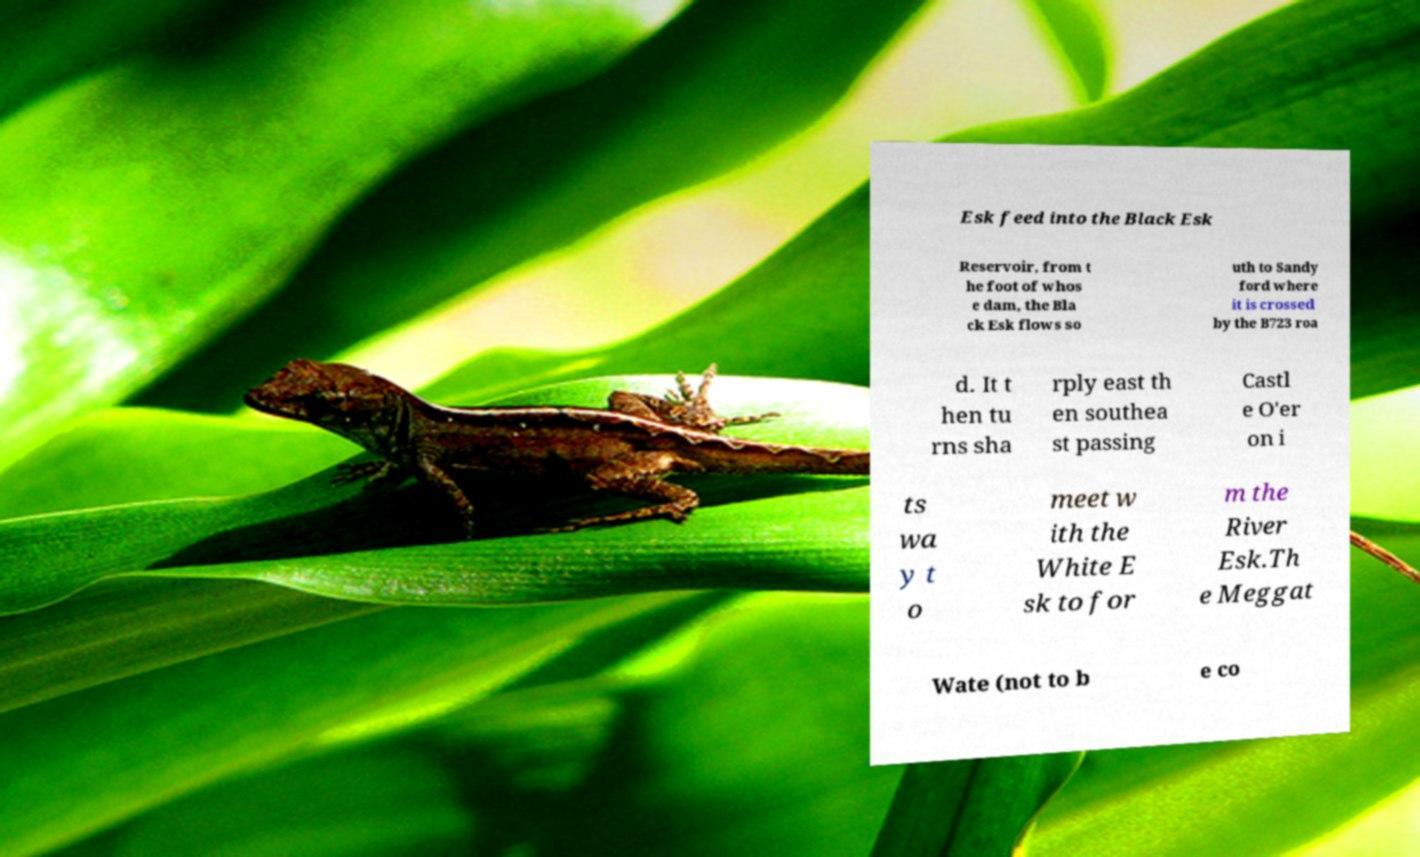Can you read and provide the text displayed in the image?This photo seems to have some interesting text. Can you extract and type it out for me? Esk feed into the Black Esk Reservoir, from t he foot of whos e dam, the Bla ck Esk flows so uth to Sandy ford where it is crossed by the B723 roa d. It t hen tu rns sha rply east th en southea st passing Castl e O'er on i ts wa y t o meet w ith the White E sk to for m the River Esk.Th e Meggat Wate (not to b e co 